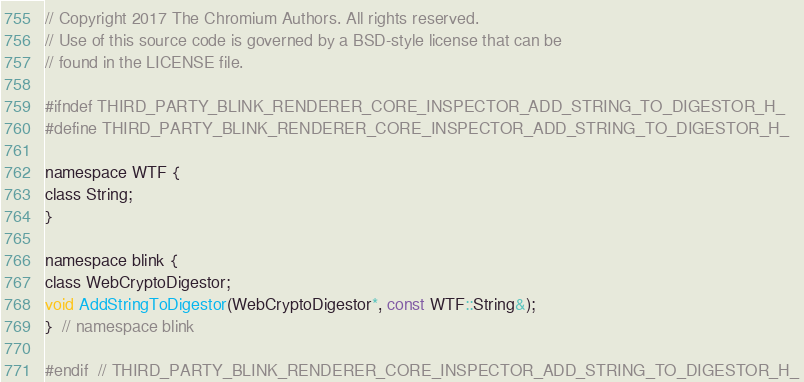<code> <loc_0><loc_0><loc_500><loc_500><_C_>// Copyright 2017 The Chromium Authors. All rights reserved.
// Use of this source code is governed by a BSD-style license that can be
// found in the LICENSE file.

#ifndef THIRD_PARTY_BLINK_RENDERER_CORE_INSPECTOR_ADD_STRING_TO_DIGESTOR_H_
#define THIRD_PARTY_BLINK_RENDERER_CORE_INSPECTOR_ADD_STRING_TO_DIGESTOR_H_

namespace WTF {
class String;
}

namespace blink {
class WebCryptoDigestor;
void AddStringToDigestor(WebCryptoDigestor*, const WTF::String&);
}  // namespace blink

#endif  // THIRD_PARTY_BLINK_RENDERER_CORE_INSPECTOR_ADD_STRING_TO_DIGESTOR_H_
</code> 